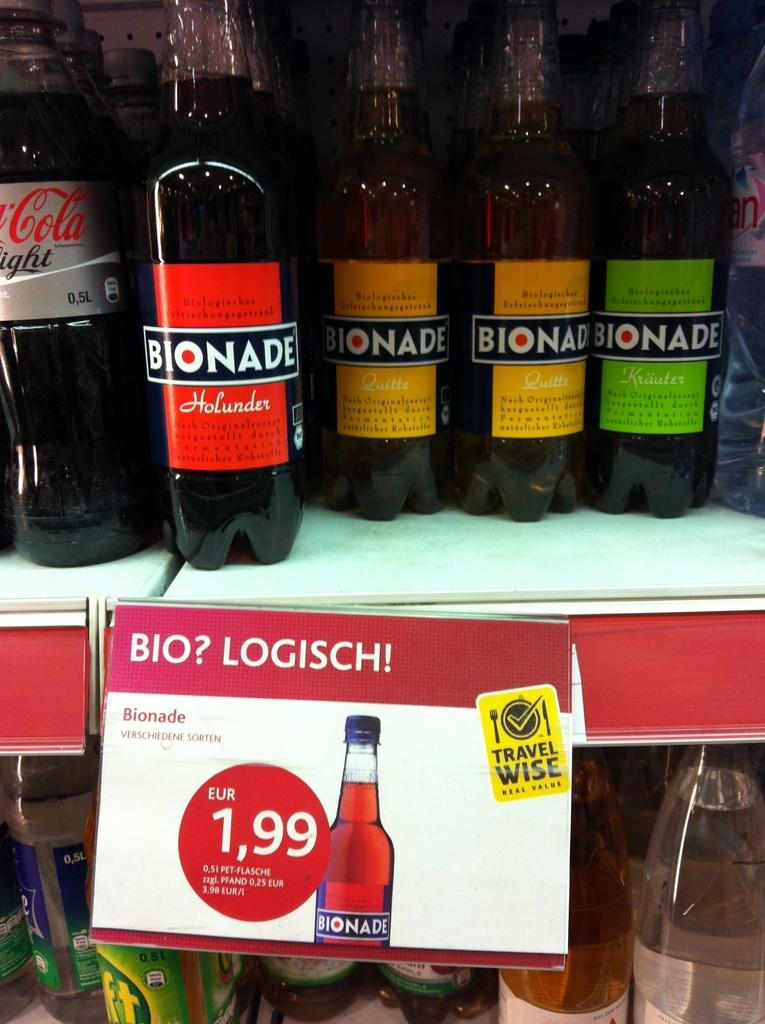Provide a one-sentence caption for the provided image. A colorful assortment of bottles of Bionade are on a shelf.. 